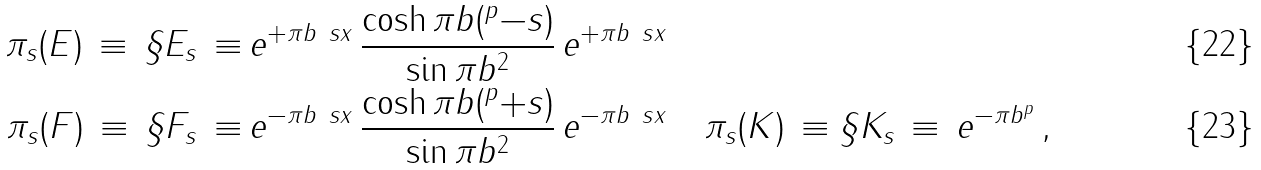<formula> <loc_0><loc_0><loc_500><loc_500>\pi _ { s } ( E ) \, \equiv \, \S E _ { s } \, \equiv \, & e ^ { + \pi b \ s x } \, \frac { \cosh \pi b ( ^ { p } - s ) } { \sin \pi b ^ { 2 } } \, e ^ { + \pi b \ s x } \\ \pi _ { s } ( F ) \, \equiv \, \S F _ { s } \, \equiv \, & e ^ { - \pi b \ s x } \, \frac { \cosh \pi b ( ^ { p } + s ) } { \sin \pi b ^ { 2 } } \, e ^ { - \pi b \ s x } \quad \pi _ { s } ( K ) \, \equiv \S K _ { s } \, \equiv \, e ^ { - \pi b ^ { p } } \, ,</formula> 